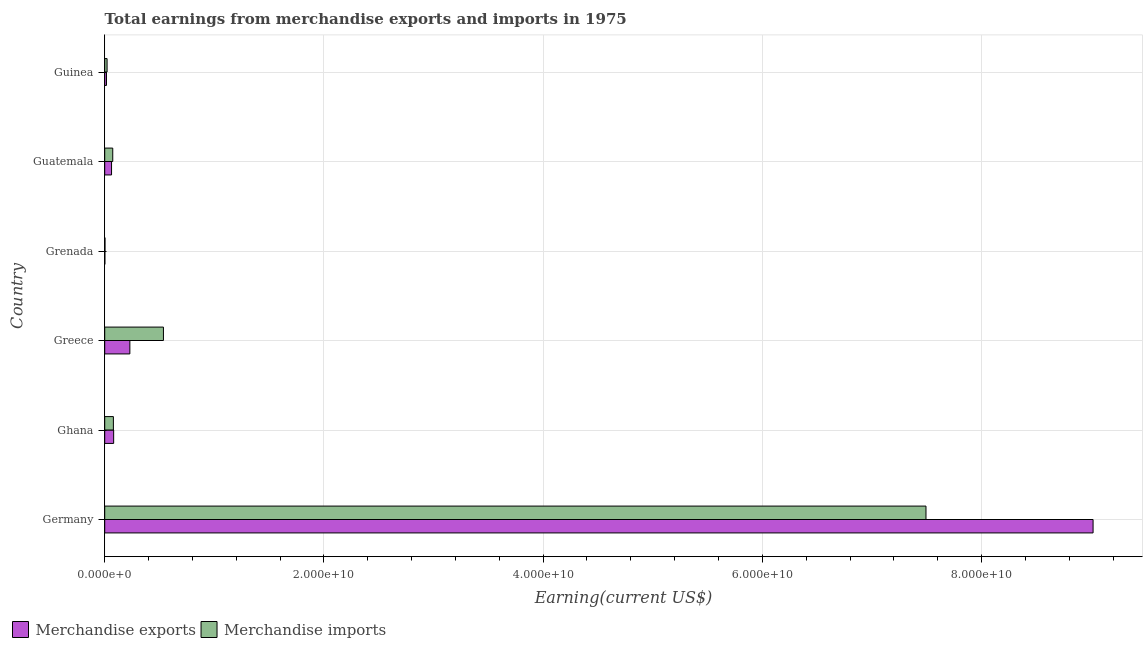How many bars are there on the 1st tick from the top?
Offer a terse response. 2. How many bars are there on the 3rd tick from the bottom?
Your answer should be compact. 2. What is the label of the 3rd group of bars from the top?
Provide a succinct answer. Grenada. In how many cases, is the number of bars for a given country not equal to the number of legend labels?
Offer a terse response. 0. What is the earnings from merchandise imports in Grenada?
Give a very brief answer. 2.41e+07. Across all countries, what is the maximum earnings from merchandise exports?
Ensure brevity in your answer.  9.02e+1. Across all countries, what is the minimum earnings from merchandise imports?
Provide a succinct answer. 2.41e+07. In which country was the earnings from merchandise exports maximum?
Your response must be concise. Germany. In which country was the earnings from merchandise imports minimum?
Ensure brevity in your answer.  Grenada. What is the total earnings from merchandise exports in the graph?
Offer a terse response. 9.41e+1. What is the difference between the earnings from merchandise imports in Ghana and that in Guinea?
Keep it short and to the point. 5.75e+08. What is the difference between the earnings from merchandise imports in Guatemala and the earnings from merchandise exports in Ghana?
Give a very brief answer. -8.33e+07. What is the average earnings from merchandise imports per country?
Your answer should be compact. 1.37e+1. What is the difference between the earnings from merchandise imports and earnings from merchandise exports in Guinea?
Make the answer very short. 5.50e+07. What is the ratio of the earnings from merchandise exports in Ghana to that in Guinea?
Provide a succinct answer. 5.07. Is the earnings from merchandise imports in Germany less than that in Ghana?
Give a very brief answer. No. What is the difference between the highest and the second highest earnings from merchandise imports?
Offer a terse response. 6.96e+1. What is the difference between the highest and the lowest earnings from merchandise imports?
Ensure brevity in your answer.  7.49e+1. What does the 1st bar from the top in Grenada represents?
Provide a succinct answer. Merchandise imports. What does the 1st bar from the bottom in Ghana represents?
Ensure brevity in your answer.  Merchandise exports. How many bars are there?
Your answer should be very brief. 12. How many countries are there in the graph?
Keep it short and to the point. 6. Are the values on the major ticks of X-axis written in scientific E-notation?
Keep it short and to the point. Yes. Does the graph contain any zero values?
Offer a terse response. No. Does the graph contain grids?
Offer a terse response. Yes. Where does the legend appear in the graph?
Your answer should be very brief. Bottom left. How many legend labels are there?
Your response must be concise. 2. How are the legend labels stacked?
Ensure brevity in your answer.  Horizontal. What is the title of the graph?
Give a very brief answer. Total earnings from merchandise exports and imports in 1975. What is the label or title of the X-axis?
Keep it short and to the point. Earning(current US$). What is the Earning(current US$) of Merchandise exports in Germany?
Your response must be concise. 9.02e+1. What is the Earning(current US$) in Merchandise imports in Germany?
Your response must be concise. 7.49e+1. What is the Earning(current US$) in Merchandise exports in Ghana?
Offer a terse response. 8.16e+08. What is the Earning(current US$) of Merchandise imports in Ghana?
Offer a terse response. 7.91e+08. What is the Earning(current US$) in Merchandise exports in Greece?
Give a very brief answer. 2.29e+09. What is the Earning(current US$) in Merchandise imports in Greece?
Give a very brief answer. 5.36e+09. What is the Earning(current US$) in Merchandise exports in Grenada?
Provide a succinct answer. 1.24e+07. What is the Earning(current US$) of Merchandise imports in Grenada?
Offer a terse response. 2.41e+07. What is the Earning(current US$) of Merchandise exports in Guatemala?
Provide a succinct answer. 6.24e+08. What is the Earning(current US$) of Merchandise imports in Guatemala?
Your answer should be very brief. 7.33e+08. What is the Earning(current US$) of Merchandise exports in Guinea?
Make the answer very short. 1.61e+08. What is the Earning(current US$) of Merchandise imports in Guinea?
Give a very brief answer. 2.16e+08. Across all countries, what is the maximum Earning(current US$) in Merchandise exports?
Offer a terse response. 9.02e+1. Across all countries, what is the maximum Earning(current US$) in Merchandise imports?
Provide a succinct answer. 7.49e+1. Across all countries, what is the minimum Earning(current US$) of Merchandise exports?
Offer a very short reply. 1.24e+07. Across all countries, what is the minimum Earning(current US$) in Merchandise imports?
Ensure brevity in your answer.  2.41e+07. What is the total Earning(current US$) of Merchandise exports in the graph?
Your answer should be very brief. 9.41e+1. What is the total Earning(current US$) in Merchandise imports in the graph?
Ensure brevity in your answer.  8.21e+1. What is the difference between the Earning(current US$) of Merchandise exports in Germany and that in Ghana?
Ensure brevity in your answer.  8.94e+1. What is the difference between the Earning(current US$) of Merchandise imports in Germany and that in Ghana?
Your answer should be compact. 7.41e+1. What is the difference between the Earning(current US$) in Merchandise exports in Germany and that in Greece?
Your answer should be compact. 8.79e+1. What is the difference between the Earning(current US$) in Merchandise imports in Germany and that in Greece?
Ensure brevity in your answer.  6.96e+1. What is the difference between the Earning(current US$) of Merchandise exports in Germany and that in Grenada?
Offer a terse response. 9.02e+1. What is the difference between the Earning(current US$) of Merchandise imports in Germany and that in Grenada?
Keep it short and to the point. 7.49e+1. What is the difference between the Earning(current US$) in Merchandise exports in Germany and that in Guatemala?
Make the answer very short. 8.96e+1. What is the difference between the Earning(current US$) in Merchandise imports in Germany and that in Guatemala?
Keep it short and to the point. 7.42e+1. What is the difference between the Earning(current US$) of Merchandise exports in Germany and that in Guinea?
Ensure brevity in your answer.  9.00e+1. What is the difference between the Earning(current US$) of Merchandise imports in Germany and that in Guinea?
Give a very brief answer. 7.47e+1. What is the difference between the Earning(current US$) of Merchandise exports in Ghana and that in Greece?
Make the answer very short. -1.48e+09. What is the difference between the Earning(current US$) in Merchandise imports in Ghana and that in Greece?
Offer a very short reply. -4.57e+09. What is the difference between the Earning(current US$) of Merchandise exports in Ghana and that in Grenada?
Your response must be concise. 8.04e+08. What is the difference between the Earning(current US$) of Merchandise imports in Ghana and that in Grenada?
Give a very brief answer. 7.67e+08. What is the difference between the Earning(current US$) of Merchandise exports in Ghana and that in Guatemala?
Offer a very short reply. 1.92e+08. What is the difference between the Earning(current US$) of Merchandise imports in Ghana and that in Guatemala?
Provide a short and direct response. 5.80e+07. What is the difference between the Earning(current US$) in Merchandise exports in Ghana and that in Guinea?
Your answer should be very brief. 6.55e+08. What is the difference between the Earning(current US$) in Merchandise imports in Ghana and that in Guinea?
Offer a very short reply. 5.75e+08. What is the difference between the Earning(current US$) of Merchandise exports in Greece and that in Grenada?
Your answer should be very brief. 2.28e+09. What is the difference between the Earning(current US$) in Merchandise imports in Greece and that in Grenada?
Your response must be concise. 5.33e+09. What is the difference between the Earning(current US$) of Merchandise exports in Greece and that in Guatemala?
Provide a short and direct response. 1.67e+09. What is the difference between the Earning(current US$) of Merchandise imports in Greece and that in Guatemala?
Offer a very short reply. 4.62e+09. What is the difference between the Earning(current US$) of Merchandise exports in Greece and that in Guinea?
Your answer should be compact. 2.13e+09. What is the difference between the Earning(current US$) in Merchandise imports in Greece and that in Guinea?
Your answer should be very brief. 5.14e+09. What is the difference between the Earning(current US$) in Merchandise exports in Grenada and that in Guatemala?
Provide a short and direct response. -6.11e+08. What is the difference between the Earning(current US$) in Merchandise imports in Grenada and that in Guatemala?
Your response must be concise. -7.09e+08. What is the difference between the Earning(current US$) in Merchandise exports in Grenada and that in Guinea?
Provide a short and direct response. -1.49e+08. What is the difference between the Earning(current US$) of Merchandise imports in Grenada and that in Guinea?
Keep it short and to the point. -1.92e+08. What is the difference between the Earning(current US$) of Merchandise exports in Guatemala and that in Guinea?
Offer a very short reply. 4.62e+08. What is the difference between the Earning(current US$) of Merchandise imports in Guatemala and that in Guinea?
Your answer should be compact. 5.17e+08. What is the difference between the Earning(current US$) of Merchandise exports in Germany and the Earning(current US$) of Merchandise imports in Ghana?
Make the answer very short. 8.94e+1. What is the difference between the Earning(current US$) in Merchandise exports in Germany and the Earning(current US$) in Merchandise imports in Greece?
Ensure brevity in your answer.  8.48e+1. What is the difference between the Earning(current US$) of Merchandise exports in Germany and the Earning(current US$) of Merchandise imports in Grenada?
Give a very brief answer. 9.02e+1. What is the difference between the Earning(current US$) in Merchandise exports in Germany and the Earning(current US$) in Merchandise imports in Guatemala?
Ensure brevity in your answer.  8.94e+1. What is the difference between the Earning(current US$) in Merchandise exports in Germany and the Earning(current US$) in Merchandise imports in Guinea?
Provide a succinct answer. 9.00e+1. What is the difference between the Earning(current US$) of Merchandise exports in Ghana and the Earning(current US$) of Merchandise imports in Greece?
Offer a terse response. -4.54e+09. What is the difference between the Earning(current US$) in Merchandise exports in Ghana and the Earning(current US$) in Merchandise imports in Grenada?
Provide a short and direct response. 7.92e+08. What is the difference between the Earning(current US$) of Merchandise exports in Ghana and the Earning(current US$) of Merchandise imports in Guatemala?
Your answer should be compact. 8.33e+07. What is the difference between the Earning(current US$) of Merchandise exports in Ghana and the Earning(current US$) of Merchandise imports in Guinea?
Keep it short and to the point. 6.00e+08. What is the difference between the Earning(current US$) of Merchandise exports in Greece and the Earning(current US$) of Merchandise imports in Grenada?
Offer a terse response. 2.27e+09. What is the difference between the Earning(current US$) in Merchandise exports in Greece and the Earning(current US$) in Merchandise imports in Guatemala?
Your answer should be very brief. 1.56e+09. What is the difference between the Earning(current US$) in Merchandise exports in Greece and the Earning(current US$) in Merchandise imports in Guinea?
Your answer should be very brief. 2.08e+09. What is the difference between the Earning(current US$) in Merchandise exports in Grenada and the Earning(current US$) in Merchandise imports in Guatemala?
Ensure brevity in your answer.  -7.20e+08. What is the difference between the Earning(current US$) in Merchandise exports in Grenada and the Earning(current US$) in Merchandise imports in Guinea?
Offer a terse response. -2.04e+08. What is the difference between the Earning(current US$) of Merchandise exports in Guatemala and the Earning(current US$) of Merchandise imports in Guinea?
Keep it short and to the point. 4.08e+08. What is the average Earning(current US$) of Merchandise exports per country?
Keep it short and to the point. 1.57e+1. What is the average Earning(current US$) of Merchandise imports per country?
Give a very brief answer. 1.37e+1. What is the difference between the Earning(current US$) in Merchandise exports and Earning(current US$) in Merchandise imports in Germany?
Give a very brief answer. 1.52e+1. What is the difference between the Earning(current US$) of Merchandise exports and Earning(current US$) of Merchandise imports in Ghana?
Offer a terse response. 2.53e+07. What is the difference between the Earning(current US$) in Merchandise exports and Earning(current US$) in Merchandise imports in Greece?
Offer a terse response. -3.06e+09. What is the difference between the Earning(current US$) of Merchandise exports and Earning(current US$) of Merchandise imports in Grenada?
Provide a short and direct response. -1.17e+07. What is the difference between the Earning(current US$) in Merchandise exports and Earning(current US$) in Merchandise imports in Guatemala?
Keep it short and to the point. -1.09e+08. What is the difference between the Earning(current US$) in Merchandise exports and Earning(current US$) in Merchandise imports in Guinea?
Provide a short and direct response. -5.50e+07. What is the ratio of the Earning(current US$) in Merchandise exports in Germany to that in Ghana?
Give a very brief answer. 110.51. What is the ratio of the Earning(current US$) of Merchandise imports in Germany to that in Ghana?
Give a very brief answer. 94.77. What is the ratio of the Earning(current US$) in Merchandise exports in Germany to that in Greece?
Give a very brief answer. 39.3. What is the ratio of the Earning(current US$) in Merchandise imports in Germany to that in Greece?
Your response must be concise. 13.99. What is the ratio of the Earning(current US$) of Merchandise exports in Germany to that in Grenada?
Give a very brief answer. 7269.12. What is the ratio of the Earning(current US$) of Merchandise imports in Germany to that in Grenada?
Offer a very short reply. 3105.54. What is the ratio of the Earning(current US$) of Merchandise exports in Germany to that in Guatemala?
Offer a very short reply. 144.63. What is the ratio of the Earning(current US$) of Merchandise imports in Germany to that in Guatemala?
Provide a short and direct response. 102.27. What is the ratio of the Earning(current US$) in Merchandise exports in Germany to that in Guinea?
Offer a terse response. 560.1. What is the ratio of the Earning(current US$) of Merchandise imports in Germany to that in Guinea?
Your response must be concise. 346.9. What is the ratio of the Earning(current US$) in Merchandise exports in Ghana to that in Greece?
Your answer should be very brief. 0.36. What is the ratio of the Earning(current US$) of Merchandise imports in Ghana to that in Greece?
Provide a succinct answer. 0.15. What is the ratio of the Earning(current US$) of Merchandise exports in Ghana to that in Grenada?
Provide a succinct answer. 65.78. What is the ratio of the Earning(current US$) in Merchandise imports in Ghana to that in Grenada?
Make the answer very short. 32.77. What is the ratio of the Earning(current US$) in Merchandise exports in Ghana to that in Guatemala?
Keep it short and to the point. 1.31. What is the ratio of the Earning(current US$) in Merchandise imports in Ghana to that in Guatemala?
Provide a succinct answer. 1.08. What is the ratio of the Earning(current US$) of Merchandise exports in Ghana to that in Guinea?
Your answer should be compact. 5.07. What is the ratio of the Earning(current US$) of Merchandise imports in Ghana to that in Guinea?
Provide a short and direct response. 3.66. What is the ratio of the Earning(current US$) in Merchandise exports in Greece to that in Grenada?
Offer a terse response. 184.95. What is the ratio of the Earning(current US$) of Merchandise imports in Greece to that in Grenada?
Provide a short and direct response. 222.02. What is the ratio of the Earning(current US$) in Merchandise exports in Greece to that in Guatemala?
Provide a short and direct response. 3.68. What is the ratio of the Earning(current US$) of Merchandise imports in Greece to that in Guatemala?
Offer a very short reply. 7.31. What is the ratio of the Earning(current US$) in Merchandise exports in Greece to that in Guinea?
Provide a short and direct response. 14.25. What is the ratio of the Earning(current US$) of Merchandise imports in Greece to that in Guinea?
Your response must be concise. 24.8. What is the ratio of the Earning(current US$) in Merchandise exports in Grenada to that in Guatemala?
Provide a short and direct response. 0.02. What is the ratio of the Earning(current US$) in Merchandise imports in Grenada to that in Guatemala?
Keep it short and to the point. 0.03. What is the ratio of the Earning(current US$) of Merchandise exports in Grenada to that in Guinea?
Keep it short and to the point. 0.08. What is the ratio of the Earning(current US$) in Merchandise imports in Grenada to that in Guinea?
Make the answer very short. 0.11. What is the ratio of the Earning(current US$) of Merchandise exports in Guatemala to that in Guinea?
Your answer should be very brief. 3.87. What is the ratio of the Earning(current US$) in Merchandise imports in Guatemala to that in Guinea?
Your answer should be very brief. 3.39. What is the difference between the highest and the second highest Earning(current US$) in Merchandise exports?
Make the answer very short. 8.79e+1. What is the difference between the highest and the second highest Earning(current US$) in Merchandise imports?
Make the answer very short. 6.96e+1. What is the difference between the highest and the lowest Earning(current US$) in Merchandise exports?
Ensure brevity in your answer.  9.02e+1. What is the difference between the highest and the lowest Earning(current US$) in Merchandise imports?
Ensure brevity in your answer.  7.49e+1. 